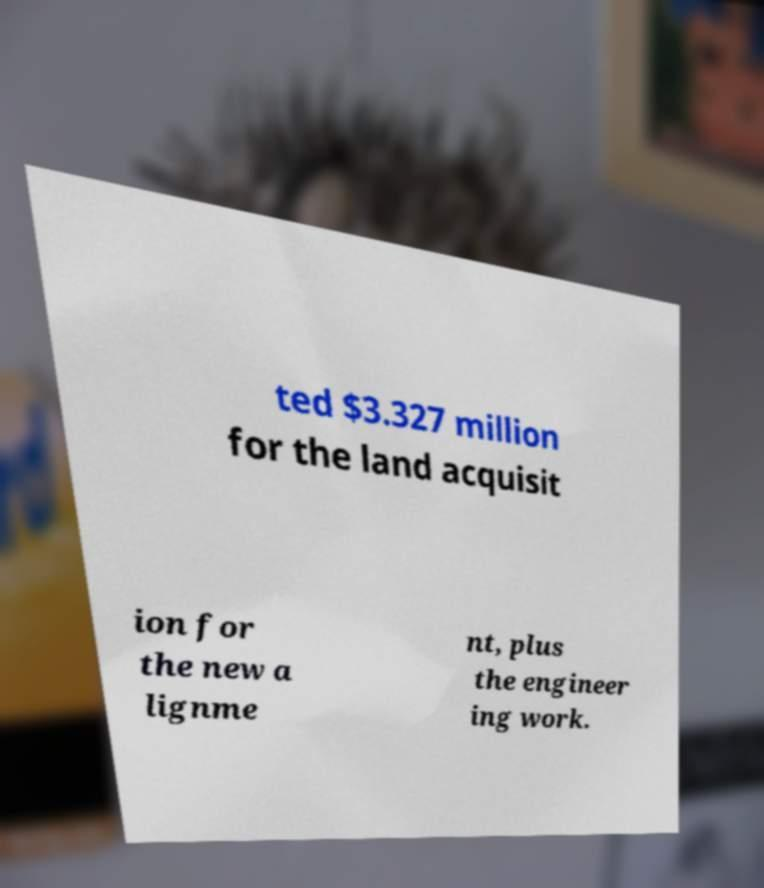There's text embedded in this image that I need extracted. Can you transcribe it verbatim? ted $3.327 million for the land acquisit ion for the new a lignme nt, plus the engineer ing work. 